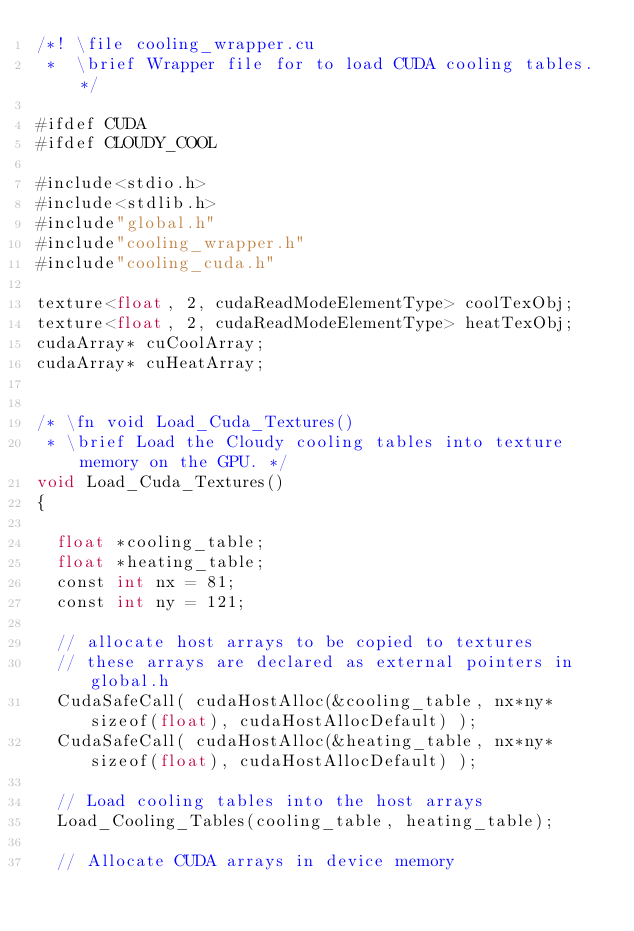Convert code to text. <code><loc_0><loc_0><loc_500><loc_500><_Cuda_>/*! \file cooling_wrapper.cu
 *  \brief Wrapper file for to load CUDA cooling tables. */

#ifdef CUDA
#ifdef CLOUDY_COOL

#include<stdio.h>
#include<stdlib.h>
#include"global.h"
#include"cooling_wrapper.h"
#include"cooling_cuda.h"

texture<float, 2, cudaReadModeElementType> coolTexObj;
texture<float, 2, cudaReadModeElementType> heatTexObj;
cudaArray* cuCoolArray;
cudaArray* cuHeatArray;


/* \fn void Load_Cuda_Textures()
 * \brief Load the Cloudy cooling tables into texture memory on the GPU. */
void Load_Cuda_Textures()
{

  float *cooling_table;
  float *heating_table;
  const int nx = 81;
  const int ny = 121;

  // allocate host arrays to be copied to textures
  // these arrays are declared as external pointers in global.h
  CudaSafeCall( cudaHostAlloc(&cooling_table, nx*ny*sizeof(float), cudaHostAllocDefault) );
  CudaSafeCall( cudaHostAlloc(&heating_table, nx*ny*sizeof(float), cudaHostAllocDefault) );

  // Load cooling tables into the host arrays
  Load_Cooling_Tables(cooling_table, heating_table);

  // Allocate CUDA arrays in device memory</code> 